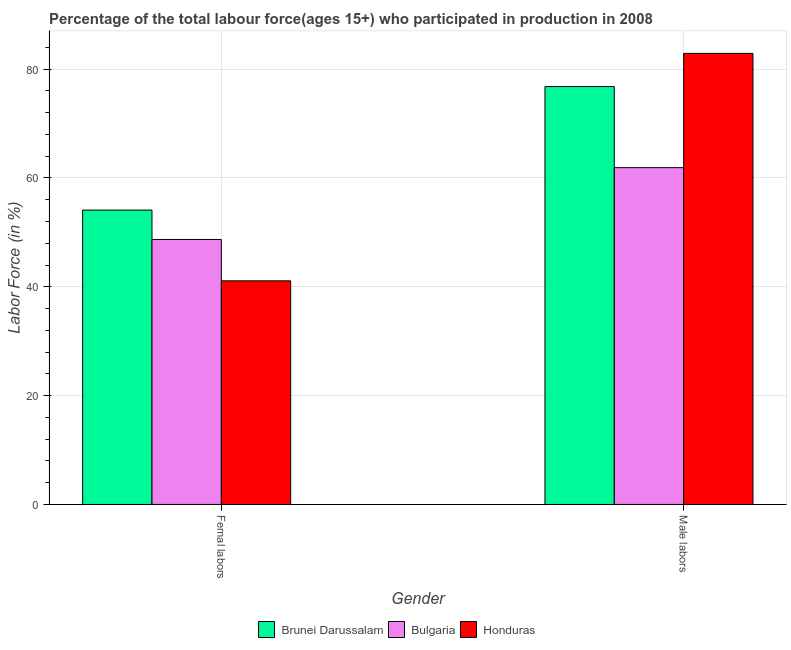How many bars are there on the 1st tick from the left?
Provide a short and direct response. 3. How many bars are there on the 1st tick from the right?
Your response must be concise. 3. What is the label of the 1st group of bars from the left?
Provide a short and direct response. Femal labors. What is the percentage of male labour force in Honduras?
Provide a short and direct response. 82.9. Across all countries, what is the maximum percentage of female labor force?
Your answer should be very brief. 54.1. Across all countries, what is the minimum percentage of female labor force?
Offer a terse response. 41.1. In which country was the percentage of female labor force maximum?
Give a very brief answer. Brunei Darussalam. In which country was the percentage of female labor force minimum?
Provide a short and direct response. Honduras. What is the total percentage of male labour force in the graph?
Your answer should be compact. 221.6. What is the difference between the percentage of female labor force in Brunei Darussalam and that in Honduras?
Provide a short and direct response. 13. What is the difference between the percentage of male labour force in Honduras and the percentage of female labor force in Bulgaria?
Ensure brevity in your answer.  34.2. What is the average percentage of female labor force per country?
Make the answer very short. 47.97. What is the difference between the percentage of male labour force and percentage of female labor force in Bulgaria?
Offer a terse response. 13.2. What is the ratio of the percentage of male labour force in Brunei Darussalam to that in Honduras?
Your answer should be compact. 0.93. Is the percentage of female labor force in Honduras less than that in Brunei Darussalam?
Your answer should be very brief. Yes. In how many countries, is the percentage of female labor force greater than the average percentage of female labor force taken over all countries?
Give a very brief answer. 2. What does the 3rd bar from the left in Male labors represents?
Make the answer very short. Honduras. Are all the bars in the graph horizontal?
Your response must be concise. No. What is the difference between two consecutive major ticks on the Y-axis?
Give a very brief answer. 20. Are the values on the major ticks of Y-axis written in scientific E-notation?
Make the answer very short. No. Where does the legend appear in the graph?
Provide a succinct answer. Bottom center. How many legend labels are there?
Your answer should be very brief. 3. What is the title of the graph?
Offer a very short reply. Percentage of the total labour force(ages 15+) who participated in production in 2008. What is the Labor Force (in %) of Brunei Darussalam in Femal labors?
Give a very brief answer. 54.1. What is the Labor Force (in %) in Bulgaria in Femal labors?
Your response must be concise. 48.7. What is the Labor Force (in %) of Honduras in Femal labors?
Offer a terse response. 41.1. What is the Labor Force (in %) in Brunei Darussalam in Male labors?
Your answer should be compact. 76.8. What is the Labor Force (in %) in Bulgaria in Male labors?
Keep it short and to the point. 61.9. What is the Labor Force (in %) of Honduras in Male labors?
Offer a very short reply. 82.9. Across all Gender, what is the maximum Labor Force (in %) in Brunei Darussalam?
Your response must be concise. 76.8. Across all Gender, what is the maximum Labor Force (in %) of Bulgaria?
Provide a succinct answer. 61.9. Across all Gender, what is the maximum Labor Force (in %) in Honduras?
Keep it short and to the point. 82.9. Across all Gender, what is the minimum Labor Force (in %) in Brunei Darussalam?
Make the answer very short. 54.1. Across all Gender, what is the minimum Labor Force (in %) of Bulgaria?
Keep it short and to the point. 48.7. Across all Gender, what is the minimum Labor Force (in %) in Honduras?
Your answer should be very brief. 41.1. What is the total Labor Force (in %) of Brunei Darussalam in the graph?
Your answer should be compact. 130.9. What is the total Labor Force (in %) in Bulgaria in the graph?
Provide a short and direct response. 110.6. What is the total Labor Force (in %) in Honduras in the graph?
Keep it short and to the point. 124. What is the difference between the Labor Force (in %) in Brunei Darussalam in Femal labors and that in Male labors?
Your answer should be compact. -22.7. What is the difference between the Labor Force (in %) in Honduras in Femal labors and that in Male labors?
Offer a very short reply. -41.8. What is the difference between the Labor Force (in %) in Brunei Darussalam in Femal labors and the Labor Force (in %) in Bulgaria in Male labors?
Provide a succinct answer. -7.8. What is the difference between the Labor Force (in %) of Brunei Darussalam in Femal labors and the Labor Force (in %) of Honduras in Male labors?
Provide a short and direct response. -28.8. What is the difference between the Labor Force (in %) in Bulgaria in Femal labors and the Labor Force (in %) in Honduras in Male labors?
Give a very brief answer. -34.2. What is the average Labor Force (in %) of Brunei Darussalam per Gender?
Make the answer very short. 65.45. What is the average Labor Force (in %) in Bulgaria per Gender?
Ensure brevity in your answer.  55.3. What is the difference between the Labor Force (in %) of Brunei Darussalam and Labor Force (in %) of Bulgaria in Femal labors?
Provide a short and direct response. 5.4. What is the difference between the Labor Force (in %) in Bulgaria and Labor Force (in %) in Honduras in Femal labors?
Make the answer very short. 7.6. What is the difference between the Labor Force (in %) of Bulgaria and Labor Force (in %) of Honduras in Male labors?
Provide a short and direct response. -21. What is the ratio of the Labor Force (in %) in Brunei Darussalam in Femal labors to that in Male labors?
Offer a terse response. 0.7. What is the ratio of the Labor Force (in %) in Bulgaria in Femal labors to that in Male labors?
Provide a succinct answer. 0.79. What is the ratio of the Labor Force (in %) of Honduras in Femal labors to that in Male labors?
Make the answer very short. 0.5. What is the difference between the highest and the second highest Labor Force (in %) in Brunei Darussalam?
Your answer should be very brief. 22.7. What is the difference between the highest and the second highest Labor Force (in %) of Honduras?
Your answer should be very brief. 41.8. What is the difference between the highest and the lowest Labor Force (in %) of Brunei Darussalam?
Provide a short and direct response. 22.7. What is the difference between the highest and the lowest Labor Force (in %) in Honduras?
Give a very brief answer. 41.8. 